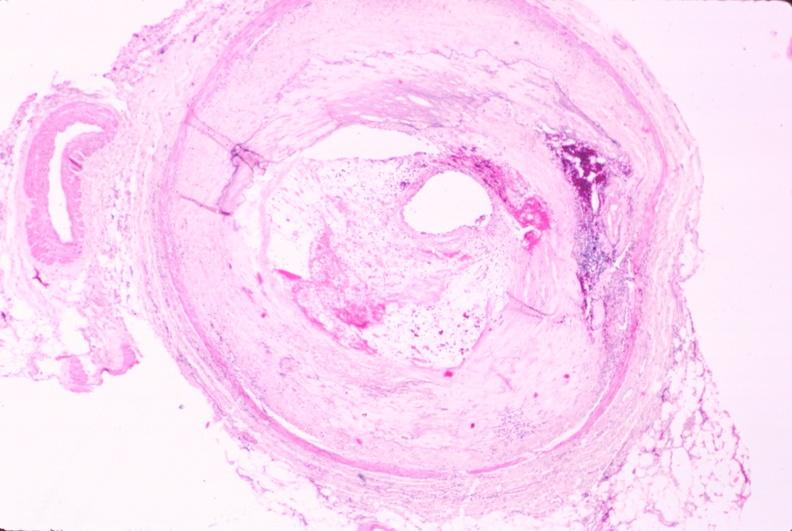s intraductal papillomatosis present?
Answer the question using a single word or phrase. No 